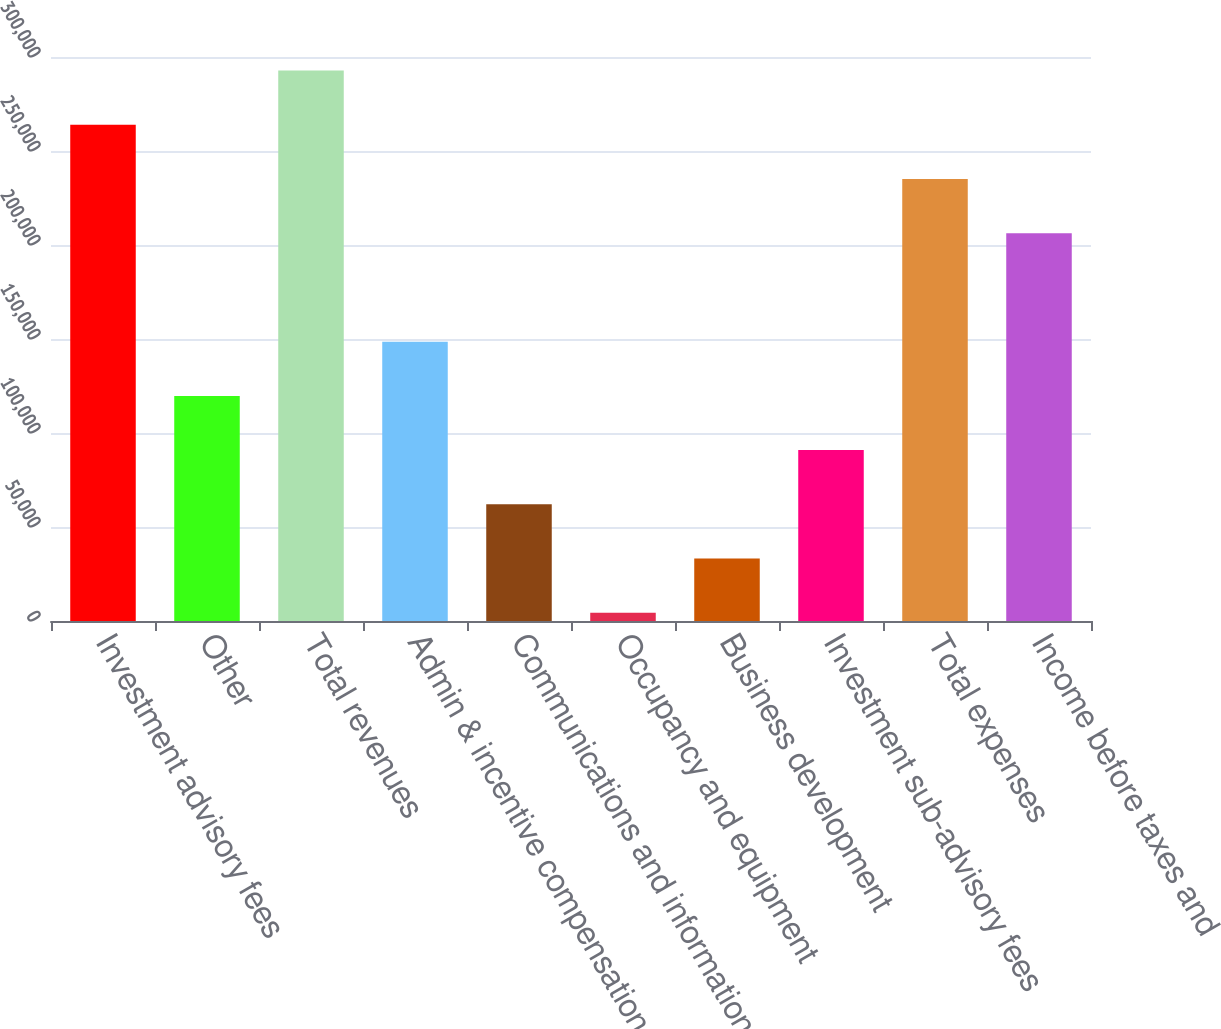Convert chart. <chart><loc_0><loc_0><loc_500><loc_500><bar_chart><fcel>Investment advisory fees<fcel>Other<fcel>Total revenues<fcel>Admin & incentive compensation<fcel>Communications and information<fcel>Occupancy and equipment<fcel>Business development<fcel>Investment sub-advisory fees<fcel>Total expenses<fcel>Income before taxes and<nl><fcel>263972<fcel>119745<fcel>292817<fcel>148590<fcel>62054.6<fcel>4364<fcel>33209.3<fcel>90899.9<fcel>235126<fcel>206281<nl></chart> 